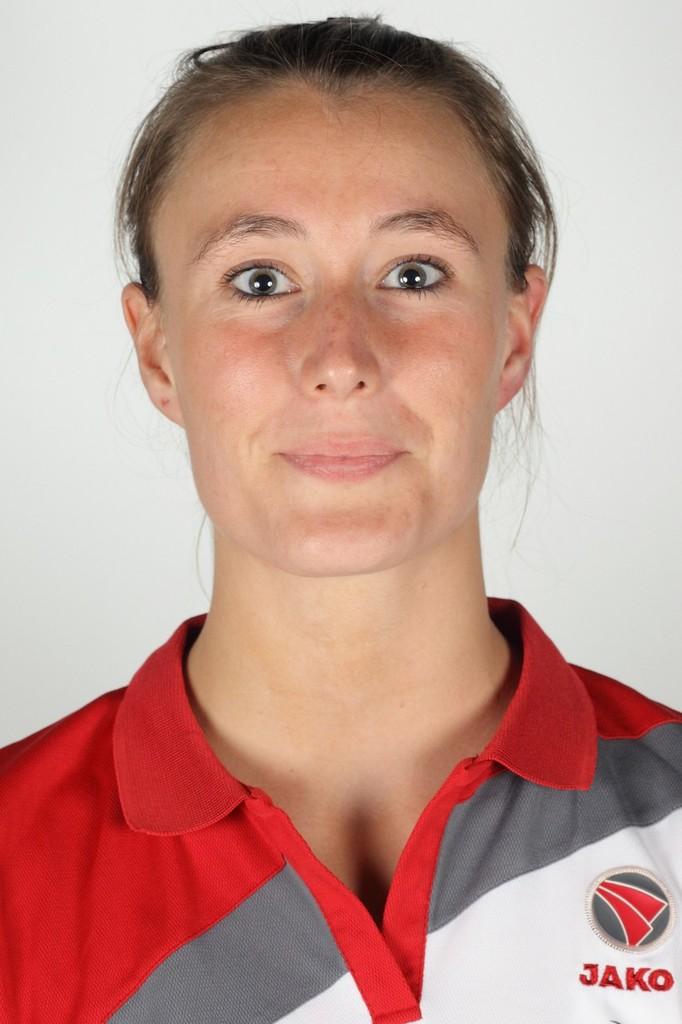What firm made this person's polo shirt?
Offer a terse response. Jako. 